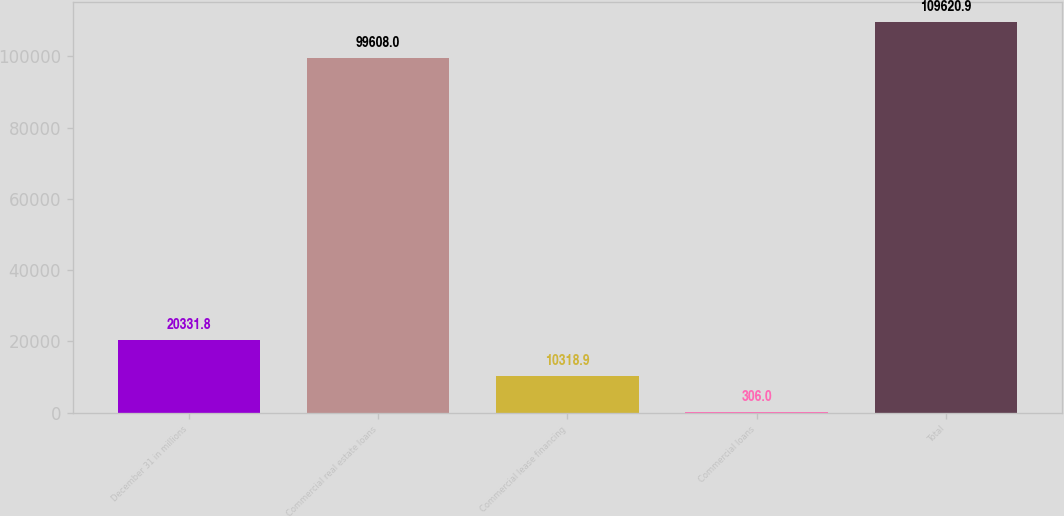<chart> <loc_0><loc_0><loc_500><loc_500><bar_chart><fcel>December 31 in millions<fcel>Commercial real estate loans<fcel>Commercial lease financing<fcel>Commercial loans<fcel>Total<nl><fcel>20331.8<fcel>99608<fcel>10318.9<fcel>306<fcel>109621<nl></chart> 